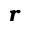<formula> <loc_0><loc_0><loc_500><loc_500>\mathbf i t { r }</formula> 